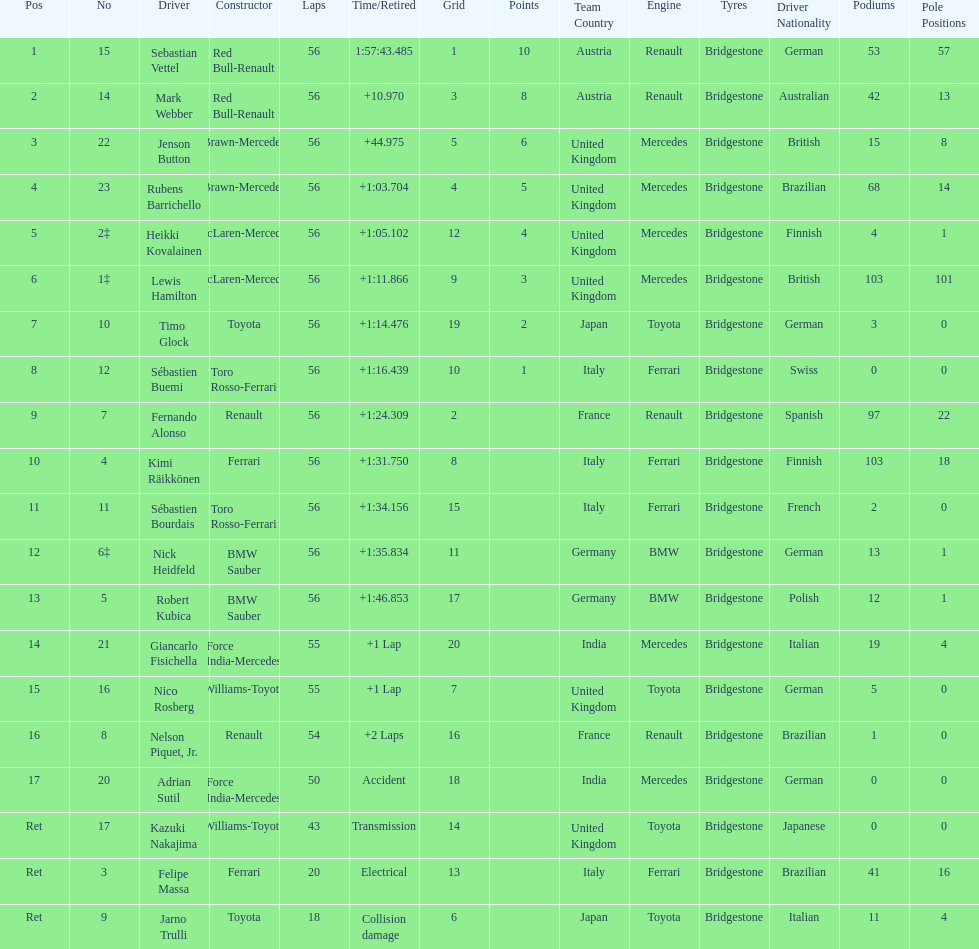How many drivers did not finish 56 laps? 7. 